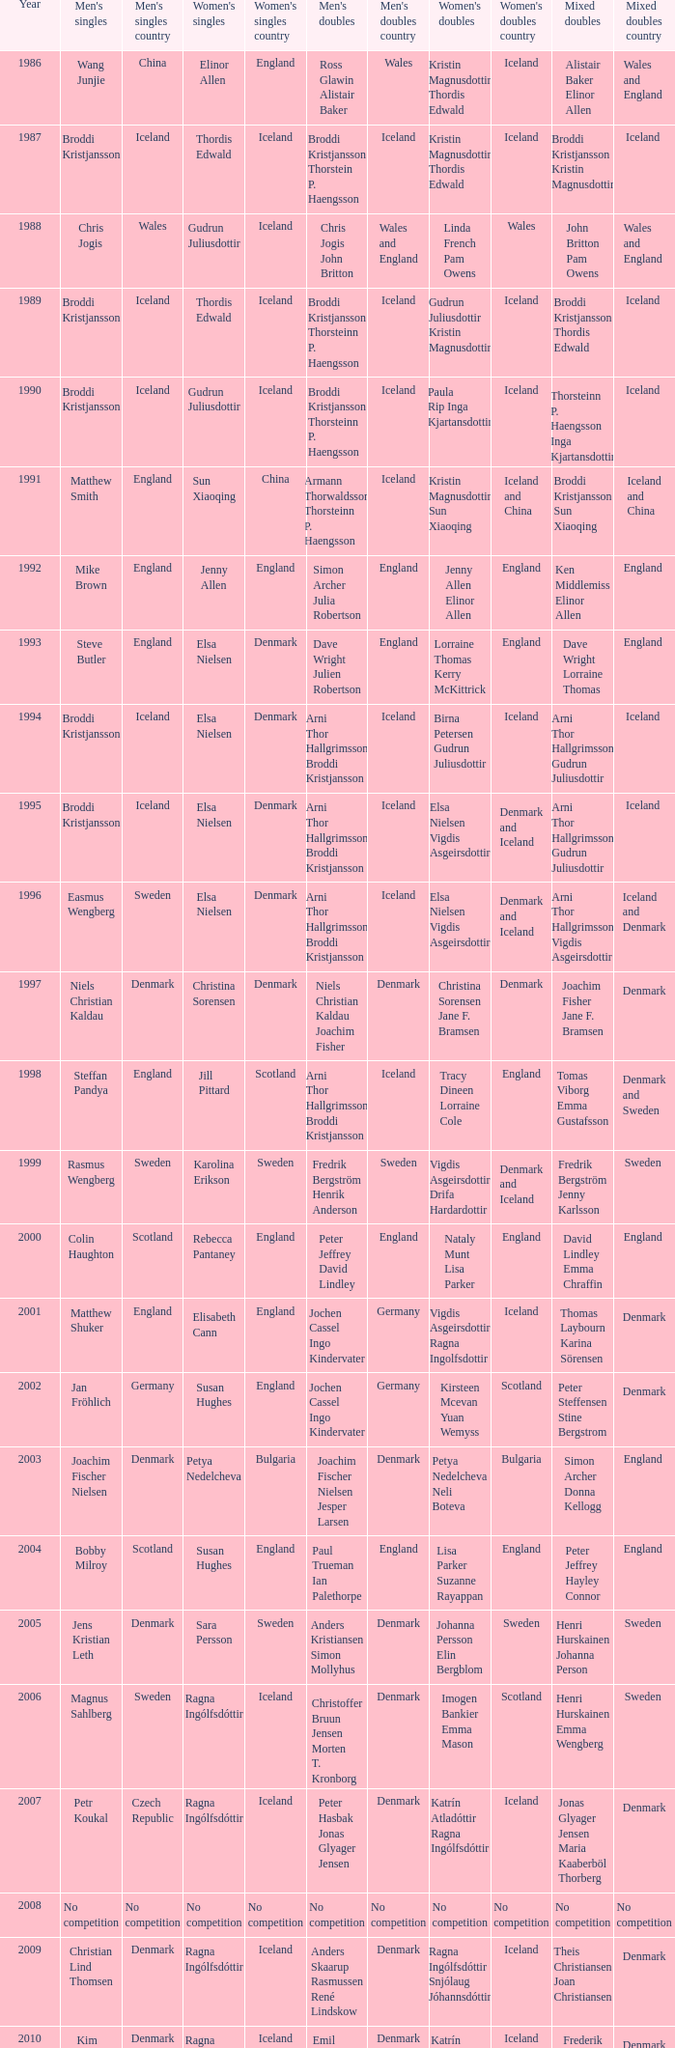Which mixed doubles happened later than 2011? Chou Tien-chen Chiang Mei-hui. 